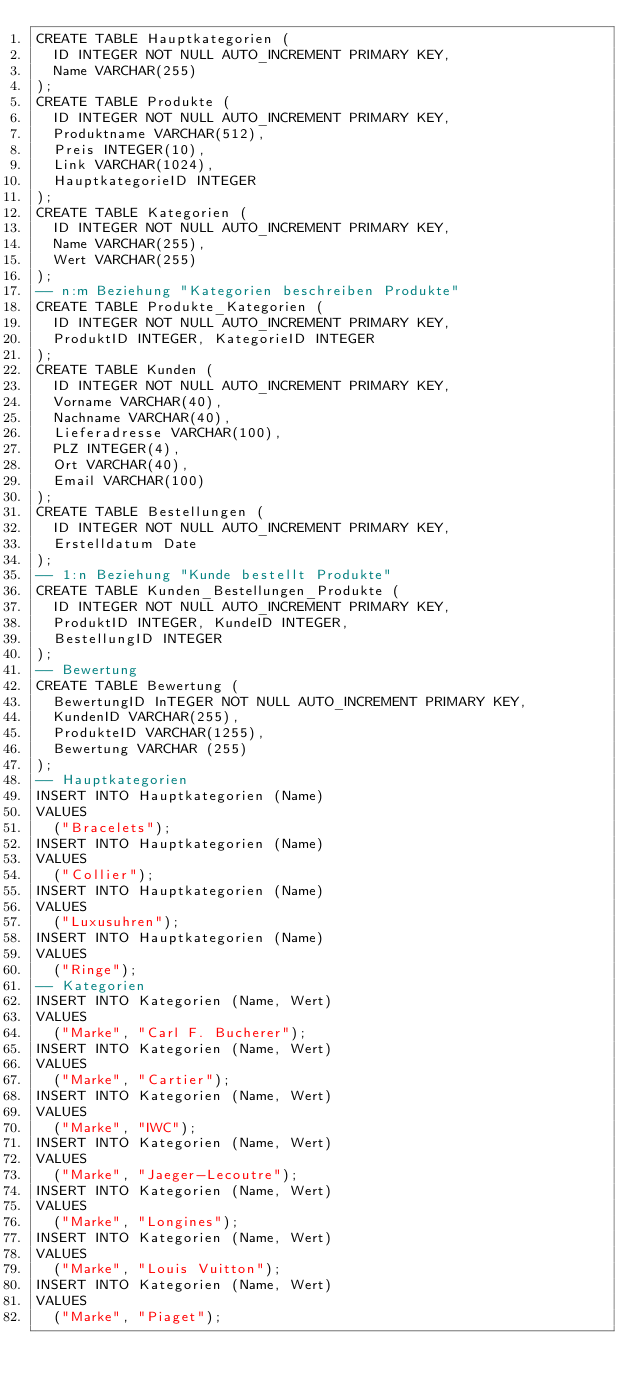<code> <loc_0><loc_0><loc_500><loc_500><_SQL_>CREATE TABLE Hauptkategorien (
  ID INTEGER NOT NULL AUTO_INCREMENT PRIMARY KEY, 
  Name VARCHAR(255)
);
CREATE TABLE Produkte (
  ID INTEGER NOT NULL AUTO_INCREMENT PRIMARY KEY, 
  Produktname VARCHAR(512), 
  Preis INTEGER(10), 
  Link VARCHAR(1024), 
  HauptkategorieID INTEGER
);
CREATE TABLE Kategorien (
  ID INTEGER NOT NULL AUTO_INCREMENT PRIMARY KEY, 
  Name VARCHAR(255), 
  Wert VARCHAR(255)
);
-- n:m Beziehung "Kategorien beschreiben Produkte"
CREATE TABLE Produkte_Kategorien (
  ID INTEGER NOT NULL AUTO_INCREMENT PRIMARY KEY, 
  ProduktID INTEGER, KategorieID INTEGER
);
CREATE TABLE Kunden (
  ID INTEGER NOT NULL AUTO_INCREMENT PRIMARY KEY, 
  Vorname VARCHAR(40), 
  Nachname VARCHAR(40), 
  Lieferadresse VARCHAR(100), 
  PLZ INTEGER(4), 
  Ort VARCHAR(40), 
  Email VARCHAR(100)
);
CREATE TABLE Bestellungen (
  ID INTEGER NOT NULL AUTO_INCREMENT PRIMARY KEY, 
  Erstelldatum Date
);
-- 1:n Beziehung "Kunde bestellt Produkte"
CREATE TABLE Kunden_Bestellungen_Produkte (
  ID INTEGER NOT NULL AUTO_INCREMENT PRIMARY KEY, 
  ProduktID INTEGER, KundeID INTEGER, 
  BestellungID INTEGER
);
-- Bewertung
CREATE TABLE Bewertung (
  BewertungID InTEGER NOT NULL AUTO_INCREMENT PRIMARY KEY, 
  KundenID VARCHAR(255), 
  ProdukteID VARCHAR(1255), 
  Bewertung VARCHAR (255)
);
-- Hauptkategorien 
INSERT INTO Hauptkategorien (Name) 
VALUES 
  ("Bracelets");
INSERT INTO Hauptkategorien (Name) 
VALUES 
  ("Collier");
INSERT INTO Hauptkategorien (Name) 
VALUES 
  ("Luxusuhren");
INSERT INTO Hauptkategorien (Name) 
VALUES 
  ("Ringe");
-- Kategorien 
INSERT INTO Kategorien (Name, Wert) 
VALUES 
  ("Marke", "Carl F. Bucherer");
INSERT INTO Kategorien (Name, Wert) 
VALUES 
  ("Marke", "Cartier");
INSERT INTO Kategorien (Name, Wert) 
VALUES 
  ("Marke", "IWC");
INSERT INTO Kategorien (Name, Wert) 
VALUES 
  ("Marke", "Jaeger-Lecoutre");
INSERT INTO Kategorien (Name, Wert) 
VALUES 
  ("Marke", "Longines");
INSERT INTO Kategorien (Name, Wert) 
VALUES 
  ("Marke", "Louis Vuitton");
INSERT INTO Kategorien (Name, Wert) 
VALUES 
  ("Marke", "Piaget");</code> 